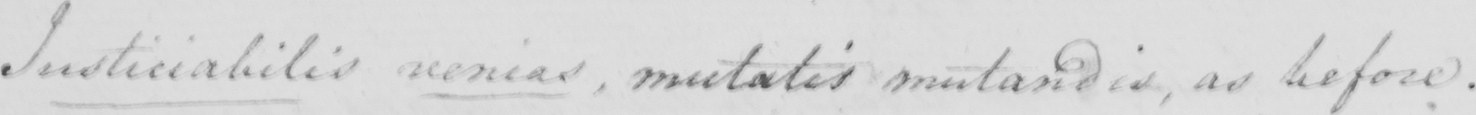Can you read and transcribe this handwriting? Justiciabilis venias  , mutatis mutandis  , as before . 